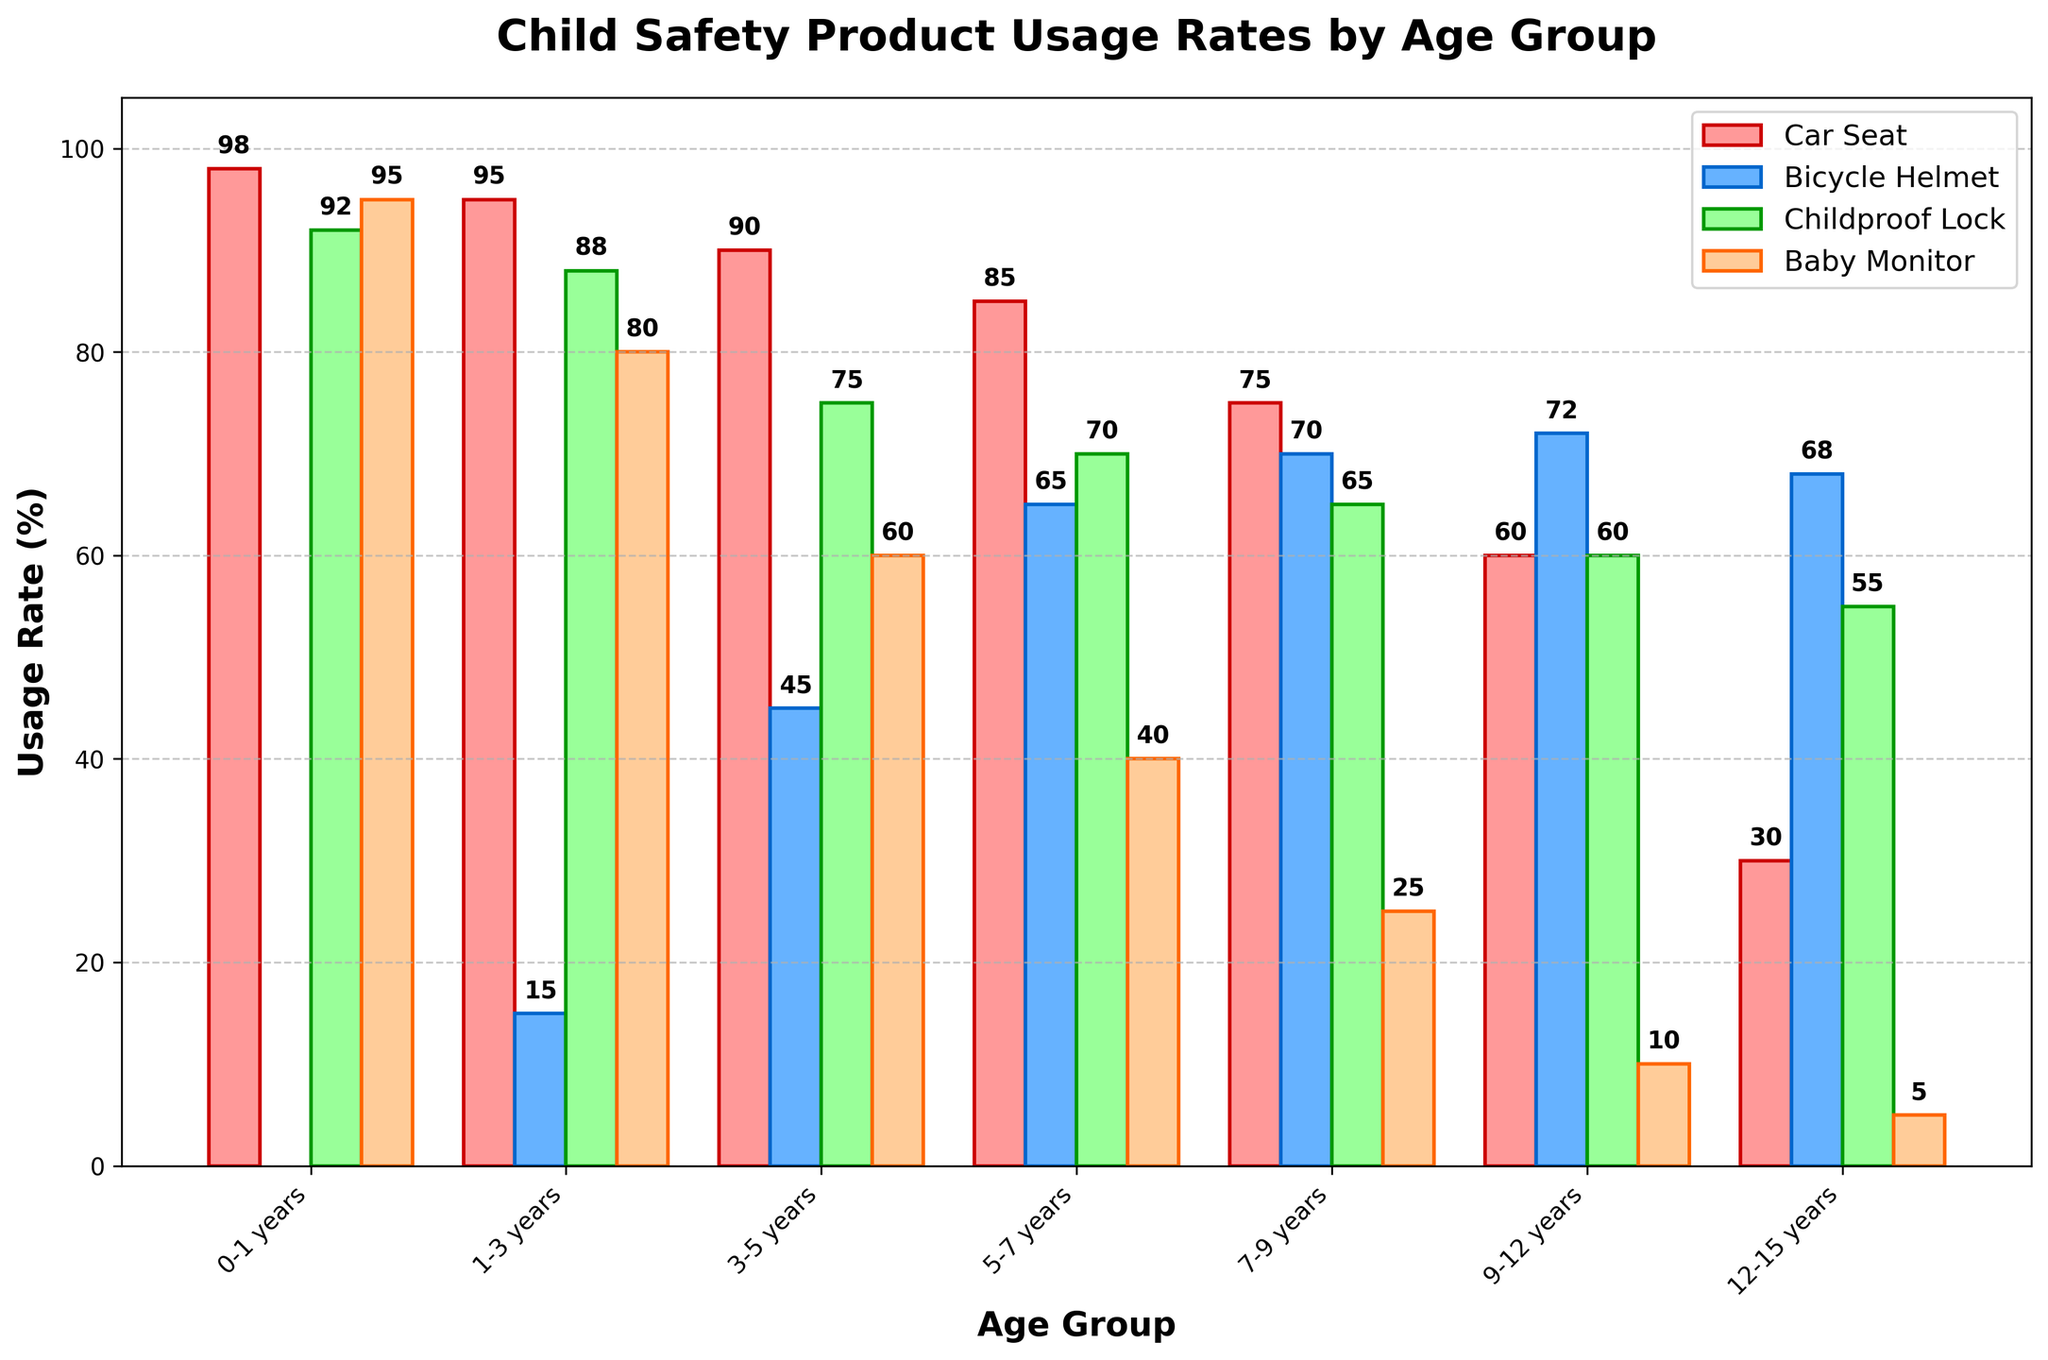What's the car seat usage rate for children aged 1-3 years? The bar corresponding to the 1-3 years age group for car seat usage is at the height of 95%
Answer: 95% By how much does bicycle helmet usage decrease from the 9-12 years age group to the 12-15 years age group? The bicycle helmet usage for 9-12 years is 72%, and for 12-15 years, it is 68%. So, the difference is 72% - 68% = 4%
Answer: 4% Which age group has the highest childproof lock usage? The highest bar for childproof lock usage corresponds to the 0-1 years age group, which is at 92%
Answer: 0-1 years Compare the bike helmet usage and baby monitor usage for children aged 5-7 years. The bar for bicycle helmet usage in the 5-7 years group is 65%, and for baby monitor usage, it is 40%. Since 65% is greater than 40%, bicycle helmet usage is higher
Answer: Bicycle helmet usage is higher Find the average usage rate of childproof locks across all age groups. Sum the percentages for childproof lock usage across all age groups and divide by the number of groups: (92 + 88 + 75 + 70 + 65 + 60 + 55) / 7 = 505 / 7 ≈ 72.14%
Answer: 72.14% How does baby monitor usage change from the 3-5 years age group to the 7-9 years age group? Baby monitor usage for 3-5 years is 60%, and for 7-9 years, it is 25%. The change is 60% - 25%, which equals a decrease of 35%
Answer: Decreases by 35% What is the difference in car seat usage rates between the 0-1 years and 12-15 years age groups? The car seat usage rate for the 0-1 years age group is 98%, and for 12-15 years age group, it is 30%. The difference is 98% - 30% = 68%
Answer: 68% Which product has the lowest usage rate in the 5-7 years age group? The bar corresponding to the baby monitor usage in the 5-7 years age group is the lowest at 40%
Answer: Baby Monitor What trend can be observed in bicycle helmet usage as age increases from 1-3 years to 12-15 years? The trend shows an overall increase in bicycle helmet usage as age increases: 15%, 45%, 65%, 70%, 72%, 68%
Answer: Increase 